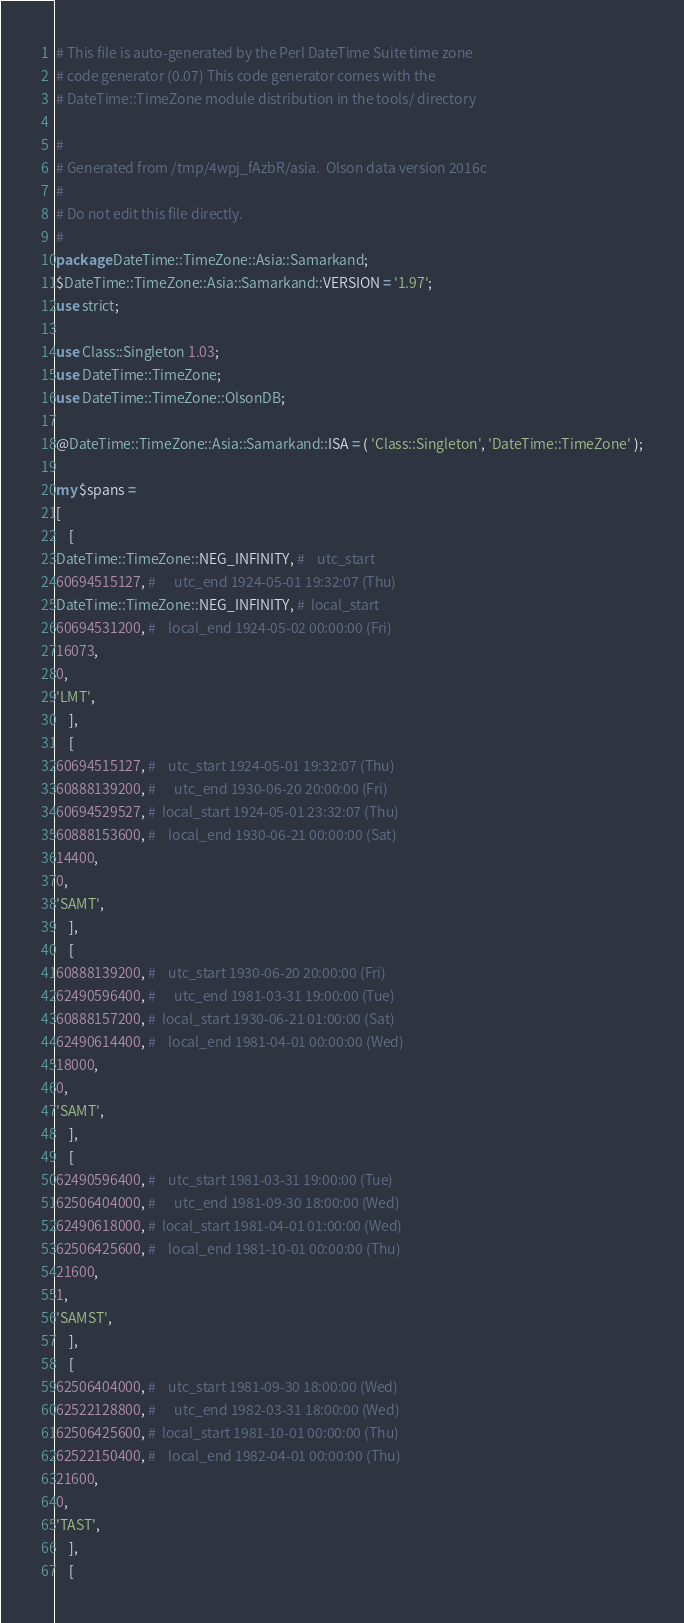<code> <loc_0><loc_0><loc_500><loc_500><_Perl_># This file is auto-generated by the Perl DateTime Suite time zone
# code generator (0.07) This code generator comes with the
# DateTime::TimeZone module distribution in the tools/ directory

#
# Generated from /tmp/4wpj_fAzbR/asia.  Olson data version 2016c
#
# Do not edit this file directly.
#
package DateTime::TimeZone::Asia::Samarkand;
$DateTime::TimeZone::Asia::Samarkand::VERSION = '1.97';
use strict;

use Class::Singleton 1.03;
use DateTime::TimeZone;
use DateTime::TimeZone::OlsonDB;

@DateTime::TimeZone::Asia::Samarkand::ISA = ( 'Class::Singleton', 'DateTime::TimeZone' );

my $spans =
[
    [
DateTime::TimeZone::NEG_INFINITY, #    utc_start
60694515127, #      utc_end 1924-05-01 19:32:07 (Thu)
DateTime::TimeZone::NEG_INFINITY, #  local_start
60694531200, #    local_end 1924-05-02 00:00:00 (Fri)
16073,
0,
'LMT',
    ],
    [
60694515127, #    utc_start 1924-05-01 19:32:07 (Thu)
60888139200, #      utc_end 1930-06-20 20:00:00 (Fri)
60694529527, #  local_start 1924-05-01 23:32:07 (Thu)
60888153600, #    local_end 1930-06-21 00:00:00 (Sat)
14400,
0,
'SAMT',
    ],
    [
60888139200, #    utc_start 1930-06-20 20:00:00 (Fri)
62490596400, #      utc_end 1981-03-31 19:00:00 (Tue)
60888157200, #  local_start 1930-06-21 01:00:00 (Sat)
62490614400, #    local_end 1981-04-01 00:00:00 (Wed)
18000,
0,
'SAMT',
    ],
    [
62490596400, #    utc_start 1981-03-31 19:00:00 (Tue)
62506404000, #      utc_end 1981-09-30 18:00:00 (Wed)
62490618000, #  local_start 1981-04-01 01:00:00 (Wed)
62506425600, #    local_end 1981-10-01 00:00:00 (Thu)
21600,
1,
'SAMST',
    ],
    [
62506404000, #    utc_start 1981-09-30 18:00:00 (Wed)
62522128800, #      utc_end 1982-03-31 18:00:00 (Wed)
62506425600, #  local_start 1981-10-01 00:00:00 (Thu)
62522150400, #    local_end 1982-04-01 00:00:00 (Thu)
21600,
0,
'TAST',
    ],
    [</code> 